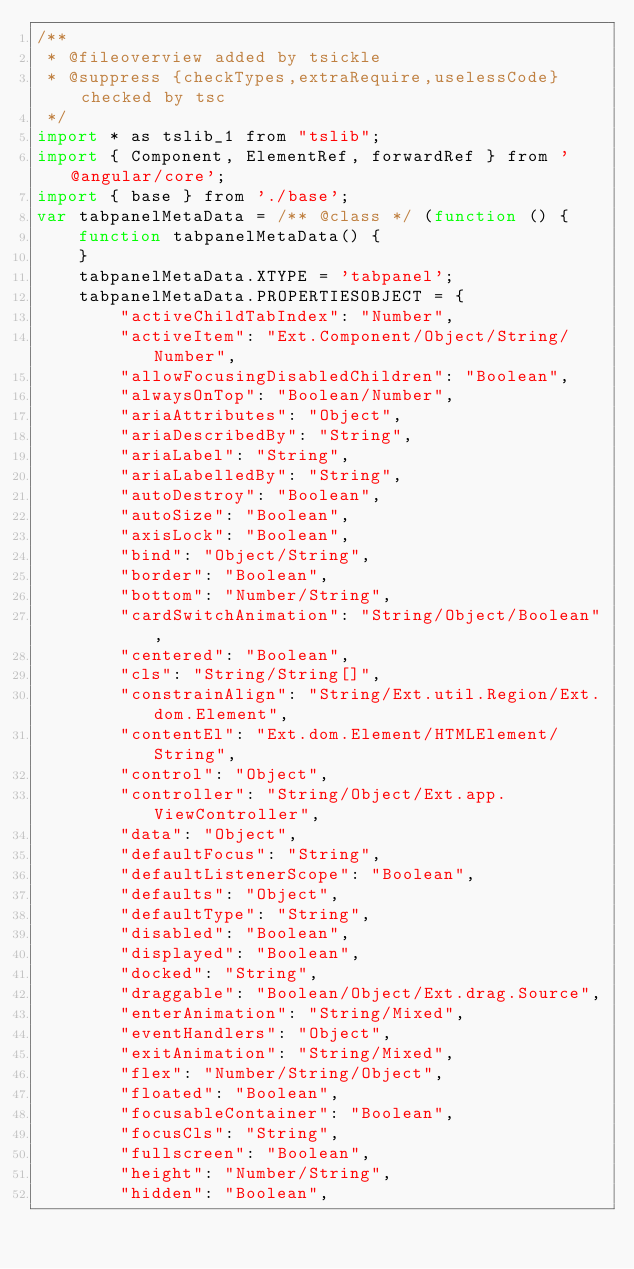<code> <loc_0><loc_0><loc_500><loc_500><_JavaScript_>/**
 * @fileoverview added by tsickle
 * @suppress {checkTypes,extraRequire,uselessCode} checked by tsc
 */
import * as tslib_1 from "tslib";
import { Component, ElementRef, forwardRef } from '@angular/core';
import { base } from './base';
var tabpanelMetaData = /** @class */ (function () {
    function tabpanelMetaData() {
    }
    tabpanelMetaData.XTYPE = 'tabpanel';
    tabpanelMetaData.PROPERTIESOBJECT = {
        "activeChildTabIndex": "Number",
        "activeItem": "Ext.Component/Object/String/Number",
        "allowFocusingDisabledChildren": "Boolean",
        "alwaysOnTop": "Boolean/Number",
        "ariaAttributes": "Object",
        "ariaDescribedBy": "String",
        "ariaLabel": "String",
        "ariaLabelledBy": "String",
        "autoDestroy": "Boolean",
        "autoSize": "Boolean",
        "axisLock": "Boolean",
        "bind": "Object/String",
        "border": "Boolean",
        "bottom": "Number/String",
        "cardSwitchAnimation": "String/Object/Boolean",
        "centered": "Boolean",
        "cls": "String/String[]",
        "constrainAlign": "String/Ext.util.Region/Ext.dom.Element",
        "contentEl": "Ext.dom.Element/HTMLElement/String",
        "control": "Object",
        "controller": "String/Object/Ext.app.ViewController",
        "data": "Object",
        "defaultFocus": "String",
        "defaultListenerScope": "Boolean",
        "defaults": "Object",
        "defaultType": "String",
        "disabled": "Boolean",
        "displayed": "Boolean",
        "docked": "String",
        "draggable": "Boolean/Object/Ext.drag.Source",
        "enterAnimation": "String/Mixed",
        "eventHandlers": "Object",
        "exitAnimation": "String/Mixed",
        "flex": "Number/String/Object",
        "floated": "Boolean",
        "focusableContainer": "Boolean",
        "focusCls": "String",
        "fullscreen": "Boolean",
        "height": "Number/String",
        "hidden": "Boolean",</code> 